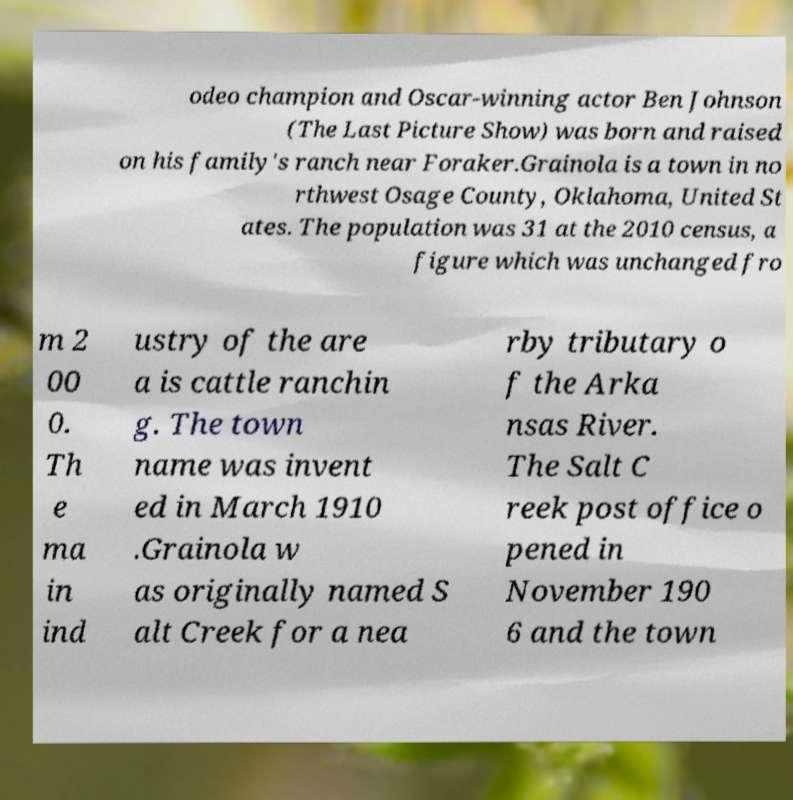For documentation purposes, I need the text within this image transcribed. Could you provide that? odeo champion and Oscar-winning actor Ben Johnson (The Last Picture Show) was born and raised on his family's ranch near Foraker.Grainola is a town in no rthwest Osage County, Oklahoma, United St ates. The population was 31 at the 2010 census, a figure which was unchanged fro m 2 00 0. Th e ma in ind ustry of the are a is cattle ranchin g. The town name was invent ed in March 1910 .Grainola w as originally named S alt Creek for a nea rby tributary o f the Arka nsas River. The Salt C reek post office o pened in November 190 6 and the town 